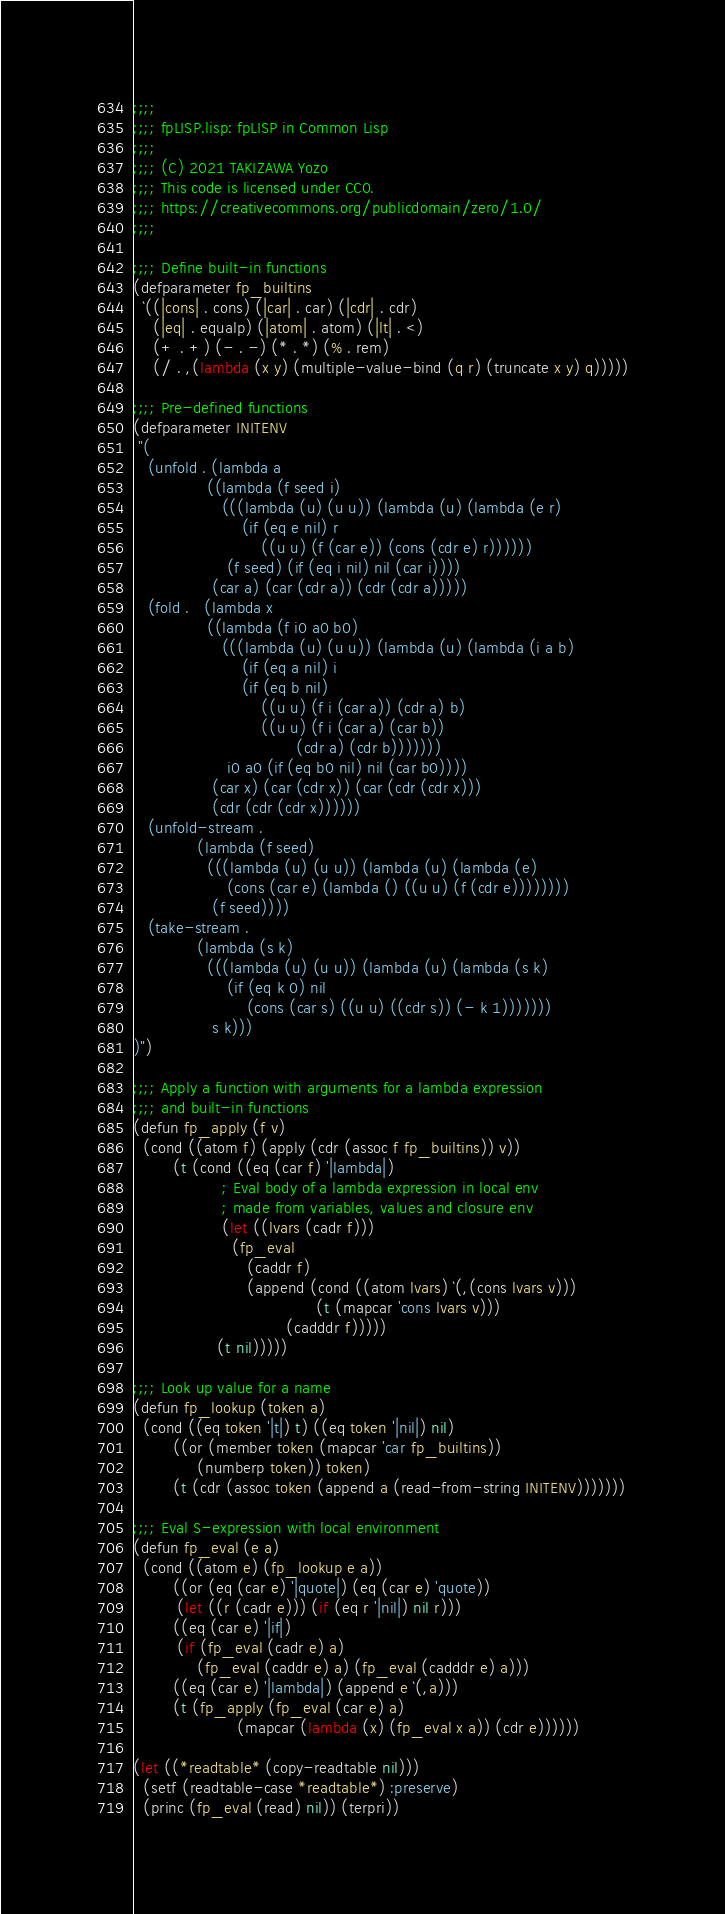<code> <loc_0><loc_0><loc_500><loc_500><_Lisp_>;;;;
;;;; fpLISP.lisp: fpLISP in Common Lisp
;;;;
;;;; (C) 2021 TAKIZAWA Yozo
;;;; This code is licensed under CC0.
;;;; https://creativecommons.org/publicdomain/zero/1.0/
;;;;

;;;; Define built-in functions
(defparameter fp_builtins
  `((|cons| . cons) (|car| . car) (|cdr| . cdr)
    (|eq| . equalp) (|atom| . atom) (|lt| . <)
    (+ . +) (- . -) (* . *) (% . rem)
    (/ . ,(lambda (x y) (multiple-value-bind (q r) (truncate x y) q)))))

;;;; Pre-defined functions
(defparameter INITENV
 "(
   (unfold . (lambda a
               ((lambda (f seed i)
                  (((lambda (u) (u u)) (lambda (u) (lambda (e r)
                      (if (eq e nil) r
                          ((u u) (f (car e)) (cons (cdr e) r))))))
                   (f seed) (if (eq i nil) nil (car i))))
                (car a) (car (cdr a)) (cdr (cdr a)))))
   (fold .   (lambda x
               ((lambda (f i0 a0 b0)
                  (((lambda (u) (u u)) (lambda (u) (lambda (i a b)
                      (if (eq a nil) i
                      (if (eq b nil)
                          ((u u) (f i (car a)) (cdr a) b)
                          ((u u) (f i (car a) (car b))
                                 (cdr a) (cdr b)))))))
                   i0 a0 (if (eq b0 nil) nil (car b0))))
                (car x) (car (cdr x)) (car (cdr (cdr x)))
                (cdr (cdr (cdr x))))))
   (unfold-stream .
             (lambda (f seed)
               (((lambda (u) (u u)) (lambda (u) (lambda (e)
                   (cons (car e) (lambda () ((u u) (f (cdr e))))))))
                (f seed))))
   (take-stream .
             (lambda (s k)
               (((lambda (u) (u u)) (lambda (u) (lambda (s k)
                   (if (eq k 0) nil
                       (cons (car s) ((u u) ((cdr s)) (- k 1)))))))
                s k)))
)")

;;;; Apply a function with arguments for a lambda expression
;;;; and built-in functions
(defun fp_apply (f v)
  (cond ((atom f) (apply (cdr (assoc f fp_builtins)) v))
        (t (cond ((eq (car f) '|lambda|)
                  ; Eval body of a lambda expression in local env
                  ; made from variables, values and closure env
                  (let ((lvars (cadr f)))
                    (fp_eval
                       (caddr f)
                       (append (cond ((atom lvars) `(,(cons lvars v)))
                                     (t (mapcar 'cons lvars v)))
                               (cadddr f)))))
                 (t nil)))))

;;;; Look up value for a name
(defun fp_lookup (token a)
  (cond ((eq token '|t|) t) ((eq token '|nil|) nil)
        ((or (member token (mapcar 'car fp_builtins))
             (numberp token)) token)
        (t (cdr (assoc token (append a (read-from-string INITENV)))))))

;;;; Eval S-expression with local environment
(defun fp_eval (e a)
  (cond ((atom e) (fp_lookup e a))
        ((or (eq (car e) '|quote|) (eq (car e) 'quote))
         (let ((r (cadr e))) (if (eq r '|nil|) nil r)))
        ((eq (car e) '|if|)
         (if (fp_eval (cadr e) a)
             (fp_eval (caddr e) a) (fp_eval (cadddr e) a)))
        ((eq (car e) '|lambda|) (append e `(,a)))
        (t (fp_apply (fp_eval (car e) a)
                     (mapcar (lambda (x) (fp_eval x a)) (cdr e))))))

(let ((*readtable* (copy-readtable nil)))
  (setf (readtable-case *readtable*) :preserve)
  (princ (fp_eval (read) nil)) (terpri))

</code> 